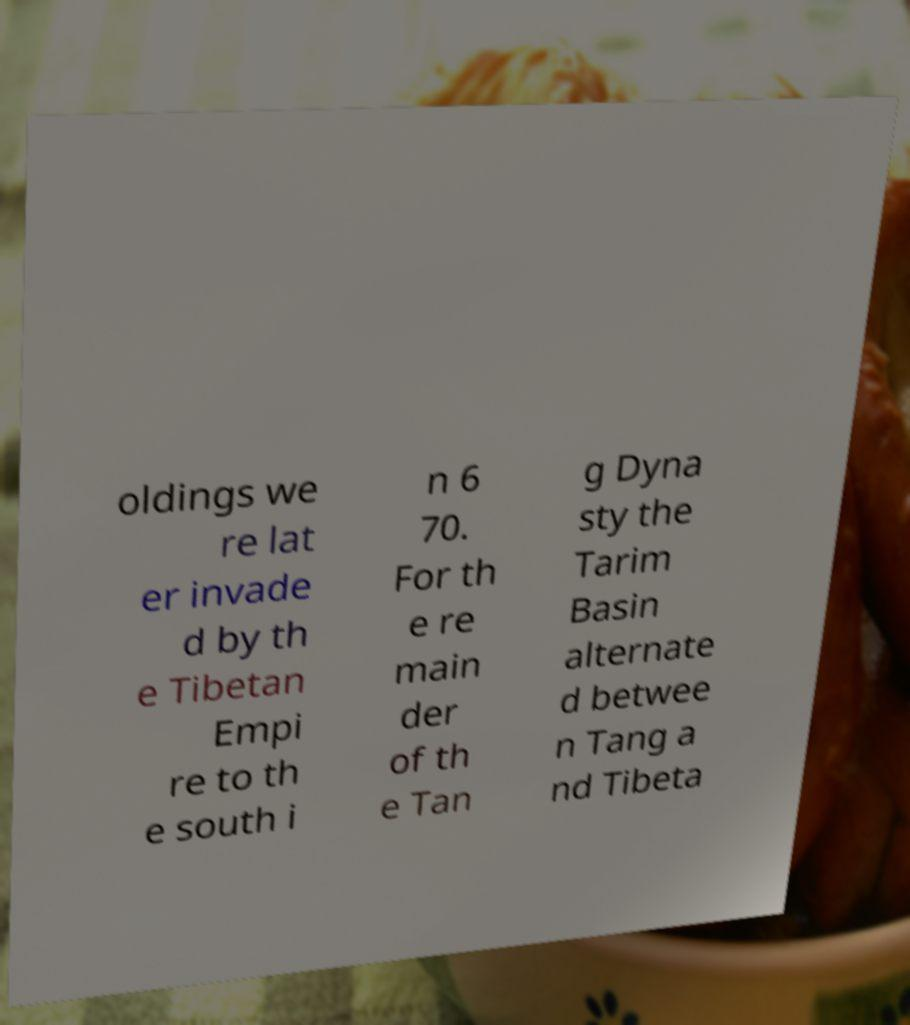For documentation purposes, I need the text within this image transcribed. Could you provide that? oldings we re lat er invade d by th e Tibetan Empi re to th e south i n 6 70. For th e re main der of th e Tan g Dyna sty the Tarim Basin alternate d betwee n Tang a nd Tibeta 